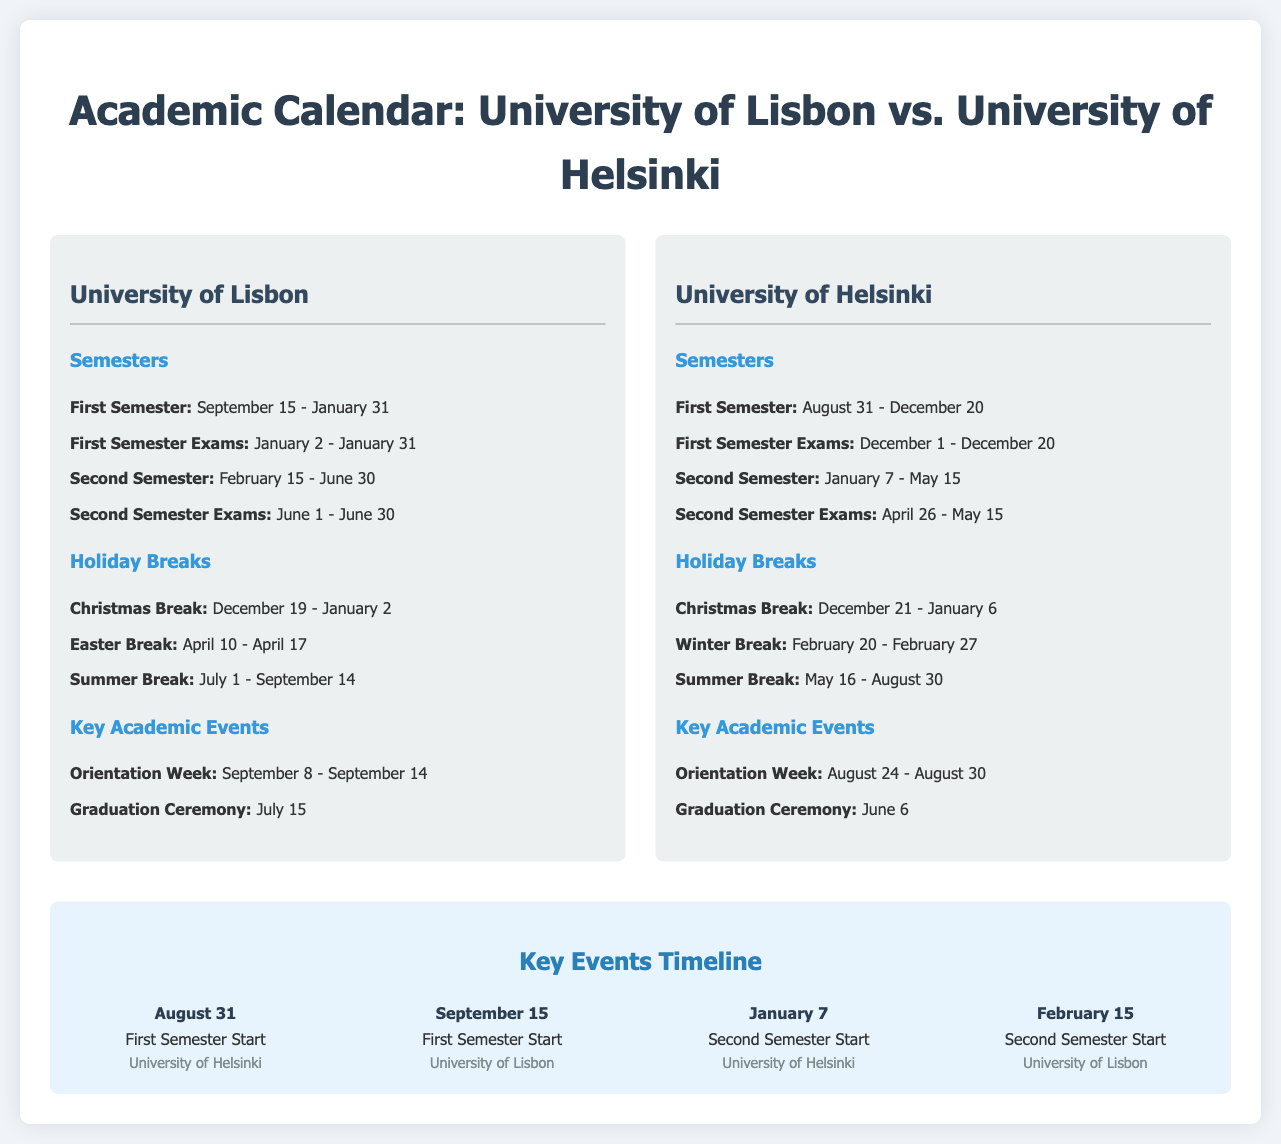What is the start date of the first semester at the University of Lisbon? The start date of the first semester at the University of Lisbon is mentioned as September 15.
Answer: September 15 What is the end date of the second semester exams at the University of Lisbon? The end date of the second semester exams is given as June 30.
Answer: June 30 When does the Easter break occur at the University of Lisbon? The document specifies the Easter break occurs from April 10 to April 17.
Answer: April 10 - April 17 How long is the Christmas break at the University of Helsinki? The document states that the Christmas break lasts from December 21 to January 6, which is a total of 17 days.
Answer: 17 days What key academic event occurs on June 6 at the University of Helsinki? The key academic event listed for June 6 is the graduation ceremony.
Answer: Graduation Ceremony Which university has a second semester starting on January 7? The information in the document identifies the University of Helsinki as having a second semester that starts on January 7.
Answer: University of Helsinki How are the semester dates visually presented in the infographic? The infographic features semester dates displayed in a side-by-side format for comparison between the two universities.
Answer: Side-by-side format What is the last date of the summer break at the University of Lisbon? The last date for the summer break is specified as September 14.
Answer: September 14 Which university has an orientation week starting on August 24? The document indicates that the University of Helsinki has an orientation week starting on August 24.
Answer: University of Helsinki 